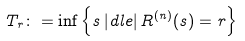<formula> <loc_0><loc_0><loc_500><loc_500>T _ { r } \colon = \inf \left \{ s \, | d l e | \, R ^ { ( n ) } ( s ) = r \right \}</formula> 